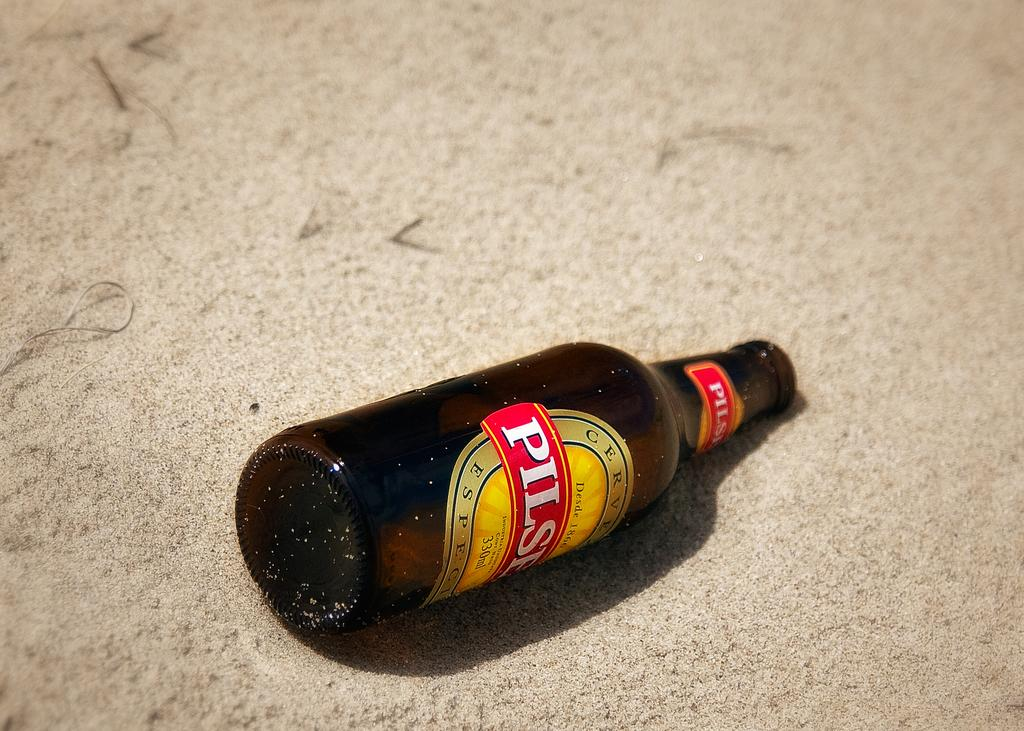<image>
Describe the image concisely. A bottle of Pilser beer lays in the sand. 